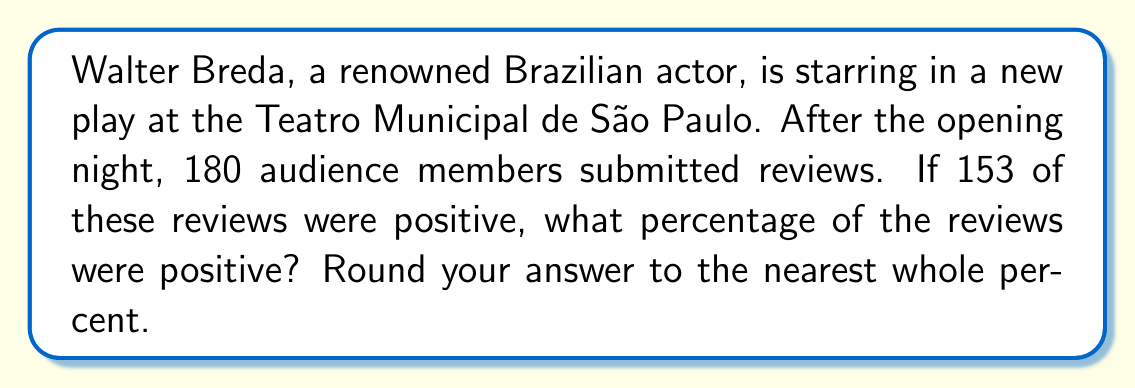Can you answer this question? To calculate the percentage of positive reviews, we need to follow these steps:

1. Identify the total number of reviews and the number of positive reviews:
   - Total reviews: 180
   - Positive reviews: 153

2. Set up the percentage formula:
   $$ \text{Percentage} = \frac{\text{Part}}{\text{Whole}} \times 100\% $$

3. Plug in the values:
   $$ \text{Percentage of positive reviews} = \frac{153}{180} \times 100\% $$

4. Perform the division:
   $$ \frac{153}{180} = 0.85 $$

5. Multiply by 100% to get the percentage:
   $$ 0.85 \times 100\% = 85\% $$

6. Round to the nearest whole percent:
   The result is already a whole number, so no rounding is necessary.

Thus, 85% of the reviews for Walter Breda's new play were positive.
Answer: 85% 